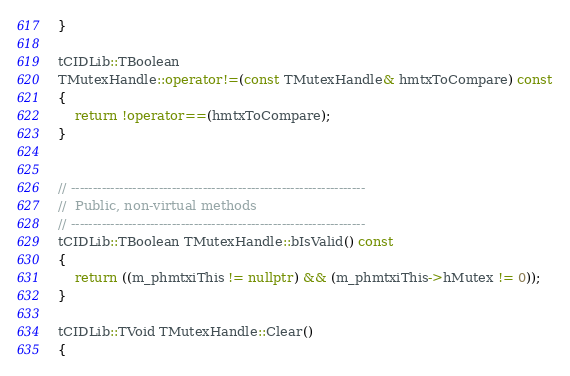<code> <loc_0><loc_0><loc_500><loc_500><_C++_>}

tCIDLib::TBoolean
TMutexHandle::operator!=(const TMutexHandle& hmtxToCompare) const
{
    return !operator==(hmtxToCompare);
}


// -------------------------------------------------------------------
//  Public, non-virtual methods
// -------------------------------------------------------------------
tCIDLib::TBoolean TMutexHandle::bIsValid() const
{
    return ((m_phmtxiThis != nullptr) && (m_phmtxiThis->hMutex != 0));
}

tCIDLib::TVoid TMutexHandle::Clear()
{</code> 